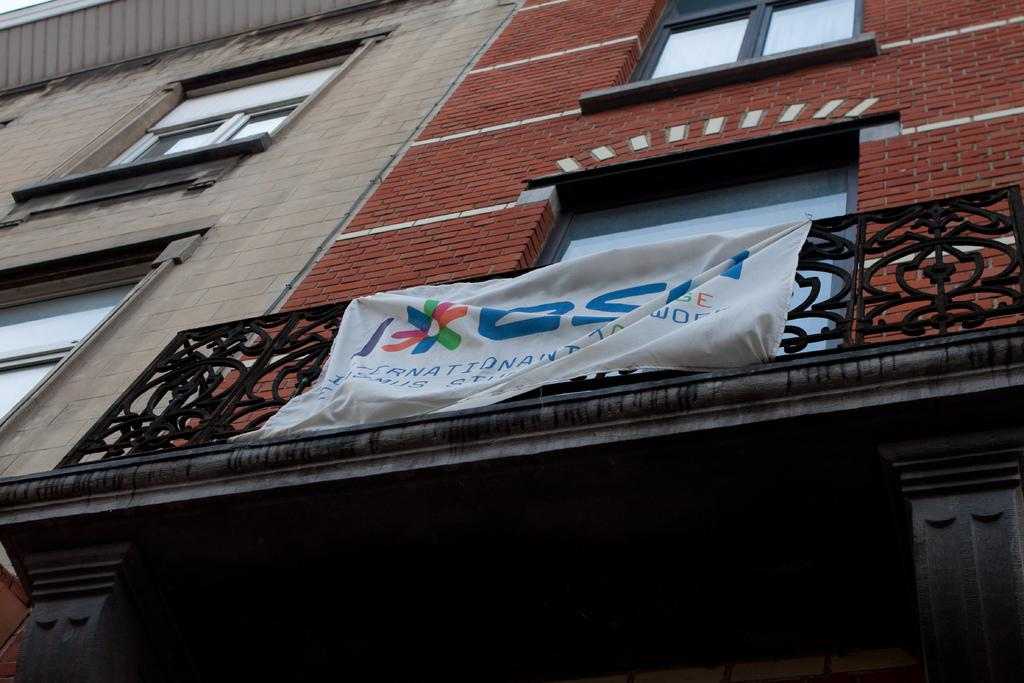What type of structure is visible in the image? There is a building in the image. Can you describe any additional features on the building? There is a banner on the railing in the image. What type of suggestion can be seen on the banner in the image? There is no suggestion visible on the banner in the image; it only contains text or a message related to the building or event. 